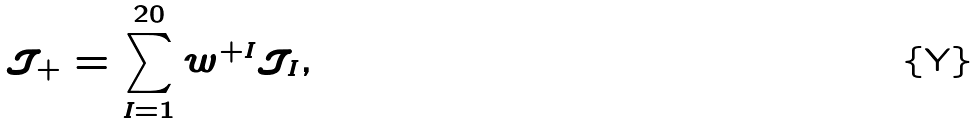Convert formula to latex. <formula><loc_0><loc_0><loc_500><loc_500>\mathcal { J } _ { + } = \sum _ { I = 1 } ^ { 2 0 } w ^ { + I } \mathcal { J } _ { I } ,</formula> 